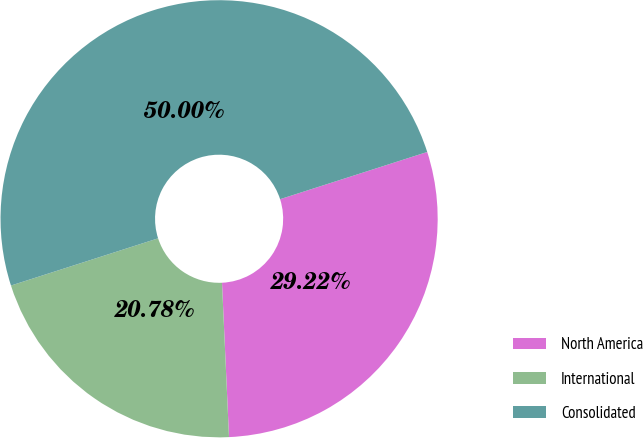<chart> <loc_0><loc_0><loc_500><loc_500><pie_chart><fcel>North America<fcel>International<fcel>Consolidated<nl><fcel>29.22%<fcel>20.78%<fcel>50.0%<nl></chart> 